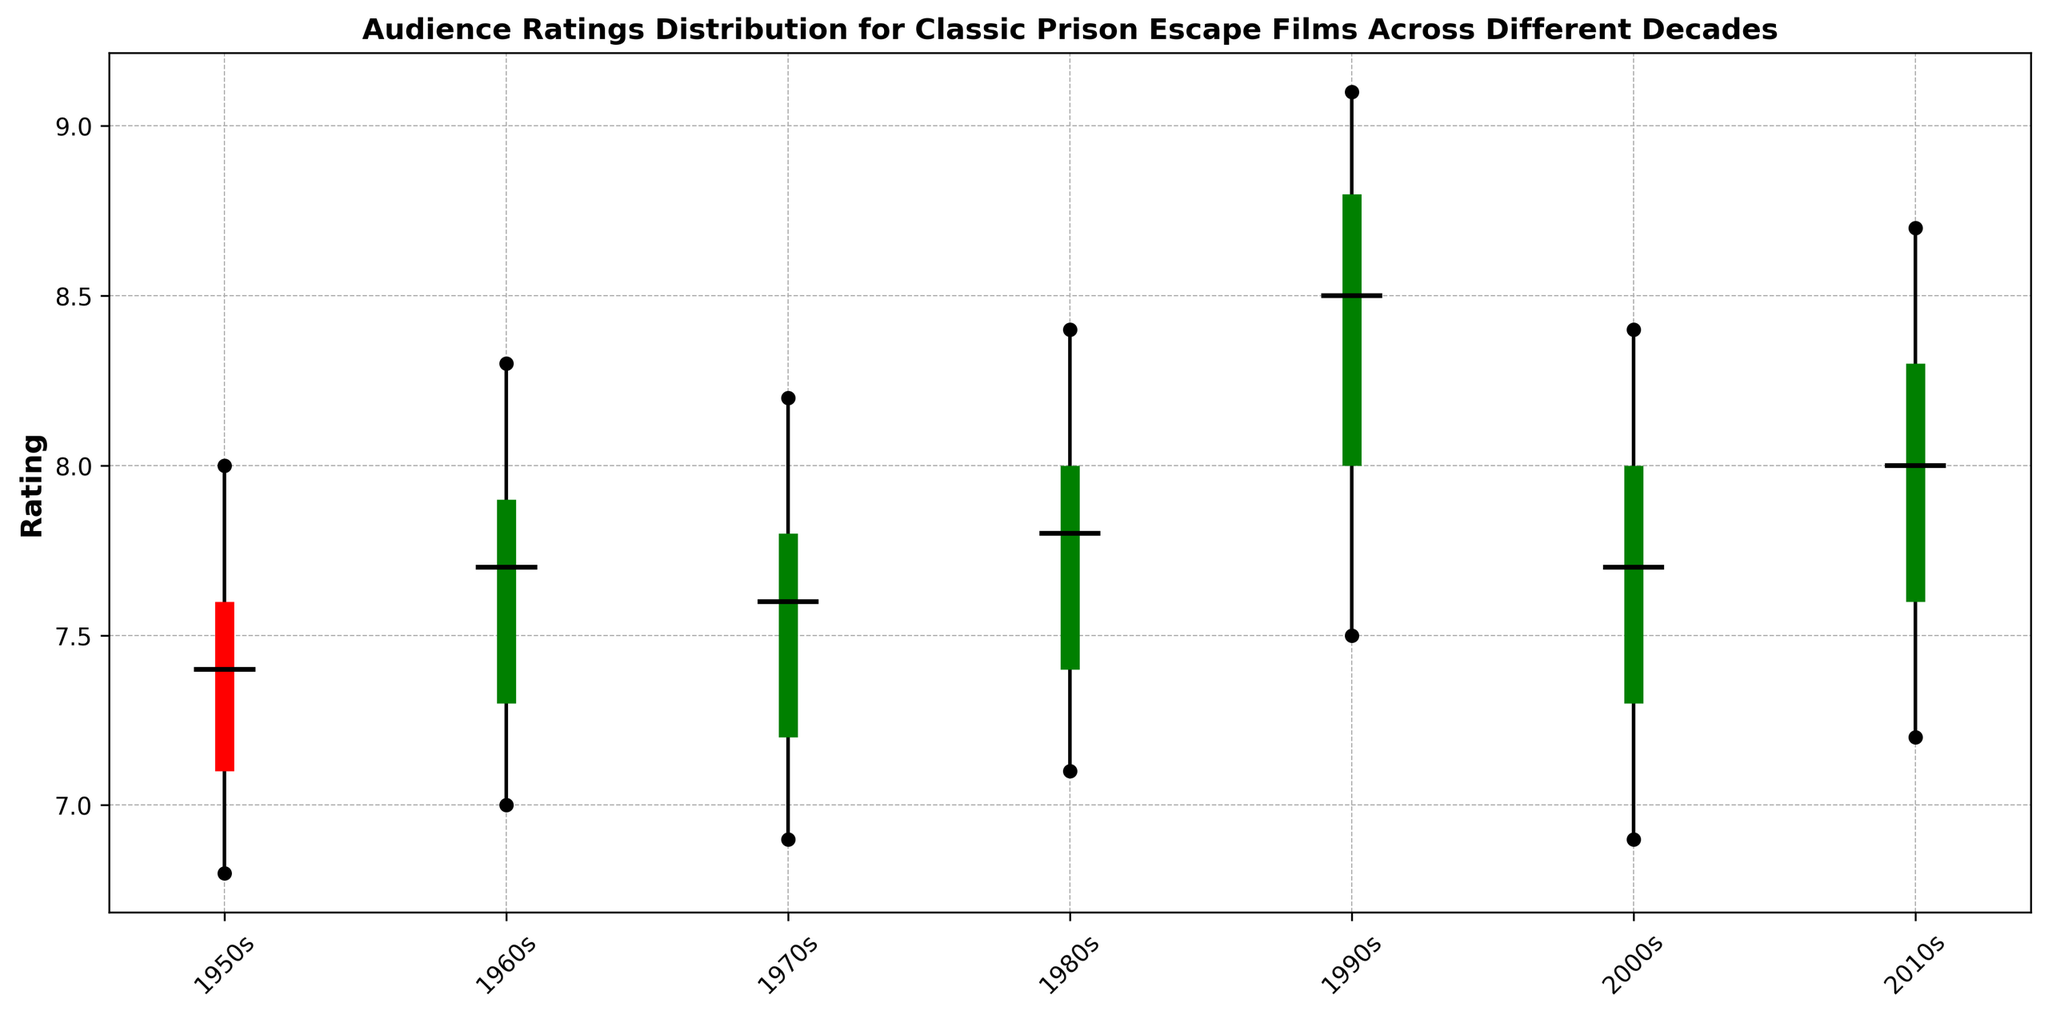What's the median rating for prison escape films from the 1990s? In the figure, locate the box representing the 1990s decade. The horizontal line inside the box denotes the median rating.
Answer: 8.5 Which decade has the lowest minimum rating? Look among the lines extending below the boxes (whiskers) for each decade and identify the shortest one vertically. The shortest line denotes the lowest minimum rating.
Answer: 1950s In which decade do we see the highest maximum rating and what is that rating? Examine the topmost part of the lines (whiskers) extending above the boxes for all decades. Find the highest endpoint and read its value.
Answer: 1990s, 9.1 Compare the median rating of the 1980s to the median rating of the 2010s. Which one is higher? Find the horizontal lines inside the boxes for both the 1980s and 2010s decades and compare their vertical positions. The higher the line, the higher the median rating.
Answer: 2010s Which decade shows the smallest interquartile range (Q3 - Q1)? For each decade, find the lengths of the green/red boxes between Q1 (bottom of the box) and Q3 (top of the box). Identify the shortest box.
Answer: 2000s Do any decades have a median rating equal to or greater than 8.0? If yes, list them. Look for horizontal lines inside the boxes marking the median ratings. Identify which lines are at or above the 8.0 mark.
Answer: 1990s, 2010s Is there any decade where the median rating is below all other interquartile ranges (Q1, Q3) of the same decade? If yes, mention the decade. Inspect the position of the median line within the boxes. It should be totally outside the Q1-Q3 range horizontally, which is rare.
Answer: None In which decades is the median rating above 7.5? Observe the horizontal lines inside the boxes and note which ones are positioned above the 7.5 mark on the rating axis.
Answer: 1990s, 2010s 